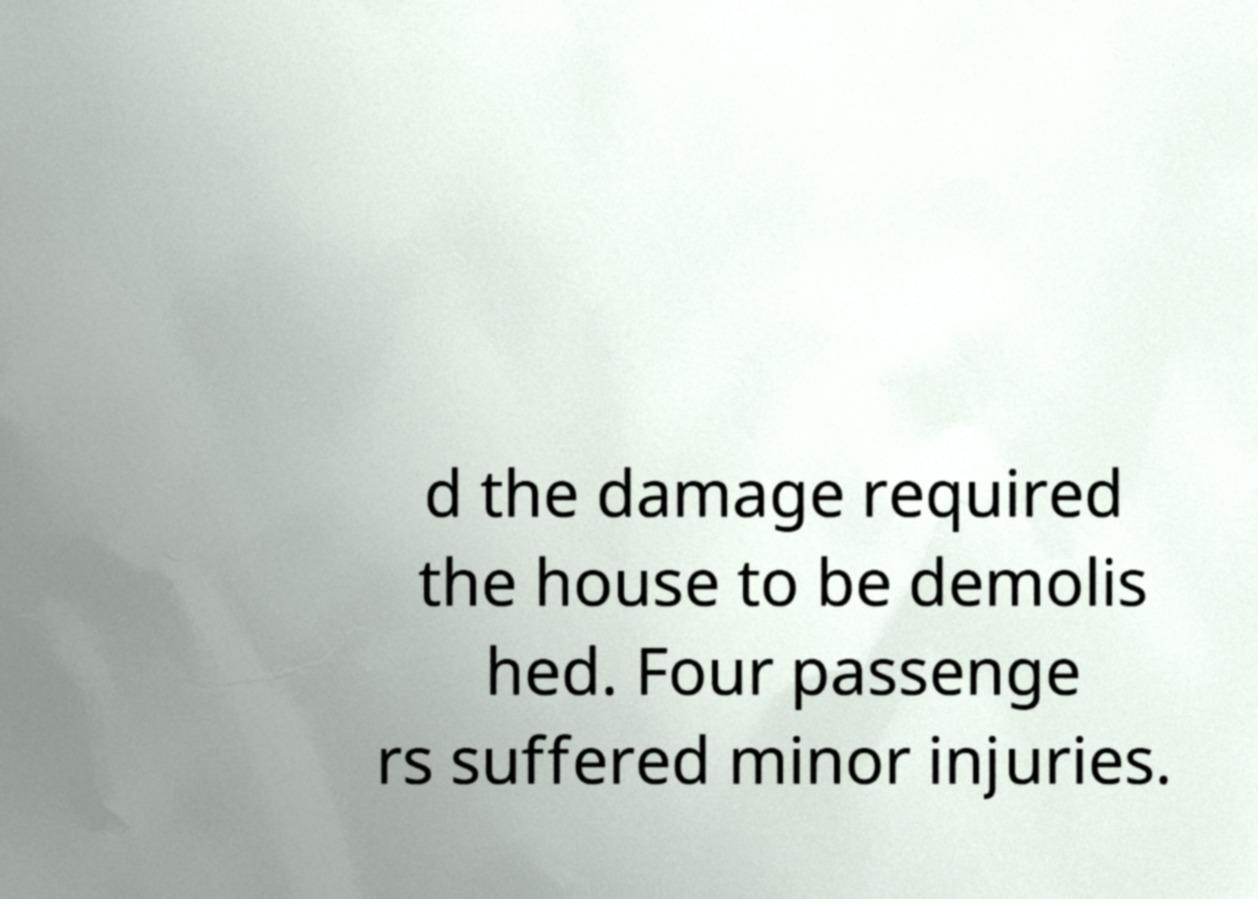Please read and relay the text visible in this image. What does it say? d the damage required the house to be demolis hed. Four passenge rs suffered minor injuries. 